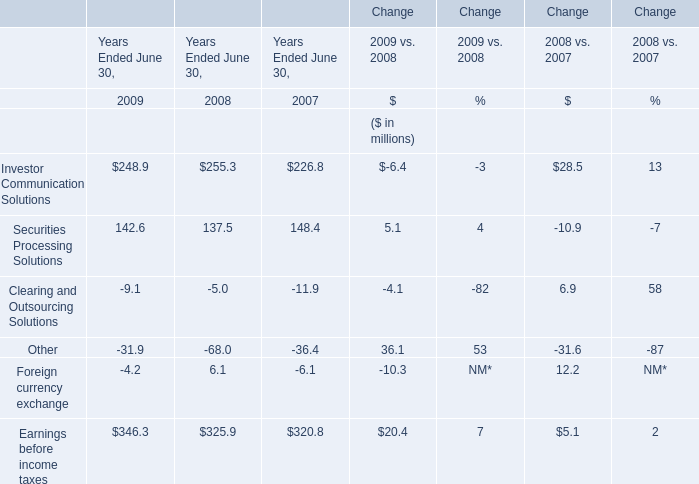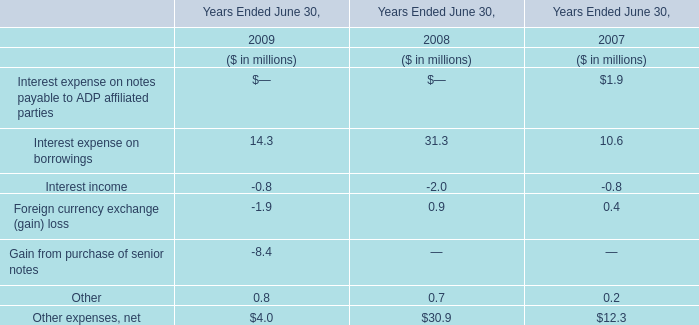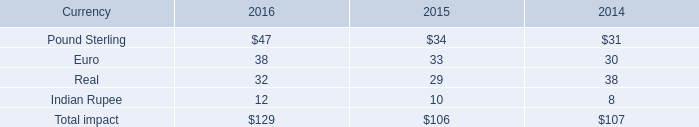what is the unfavorable foreign currency impact in operating expenses in 2016? 
Computations: (100 - 10)
Answer: 90.0. 